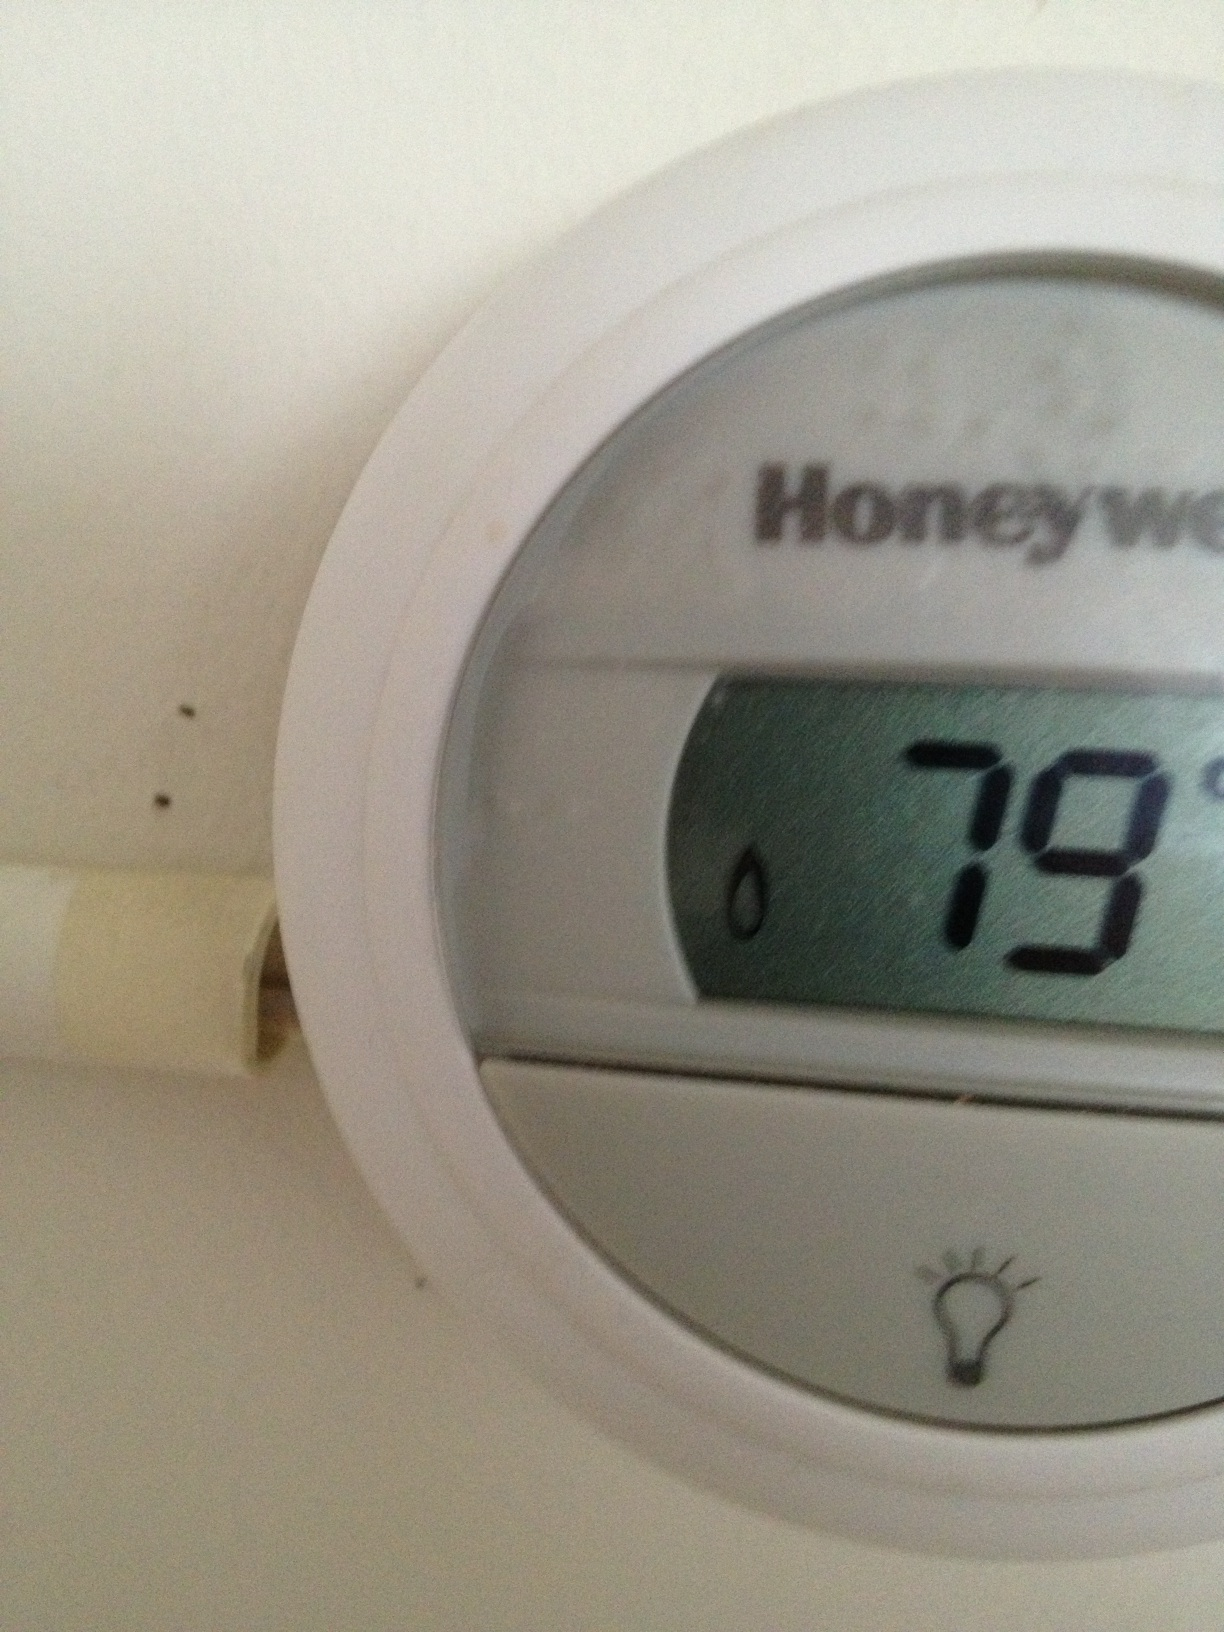What's the model of the thermostat? The thermostat in the image is manufactured by Honeywell, as indicated by the brand name on the display. The exact model cannot be determined solely from this image. 